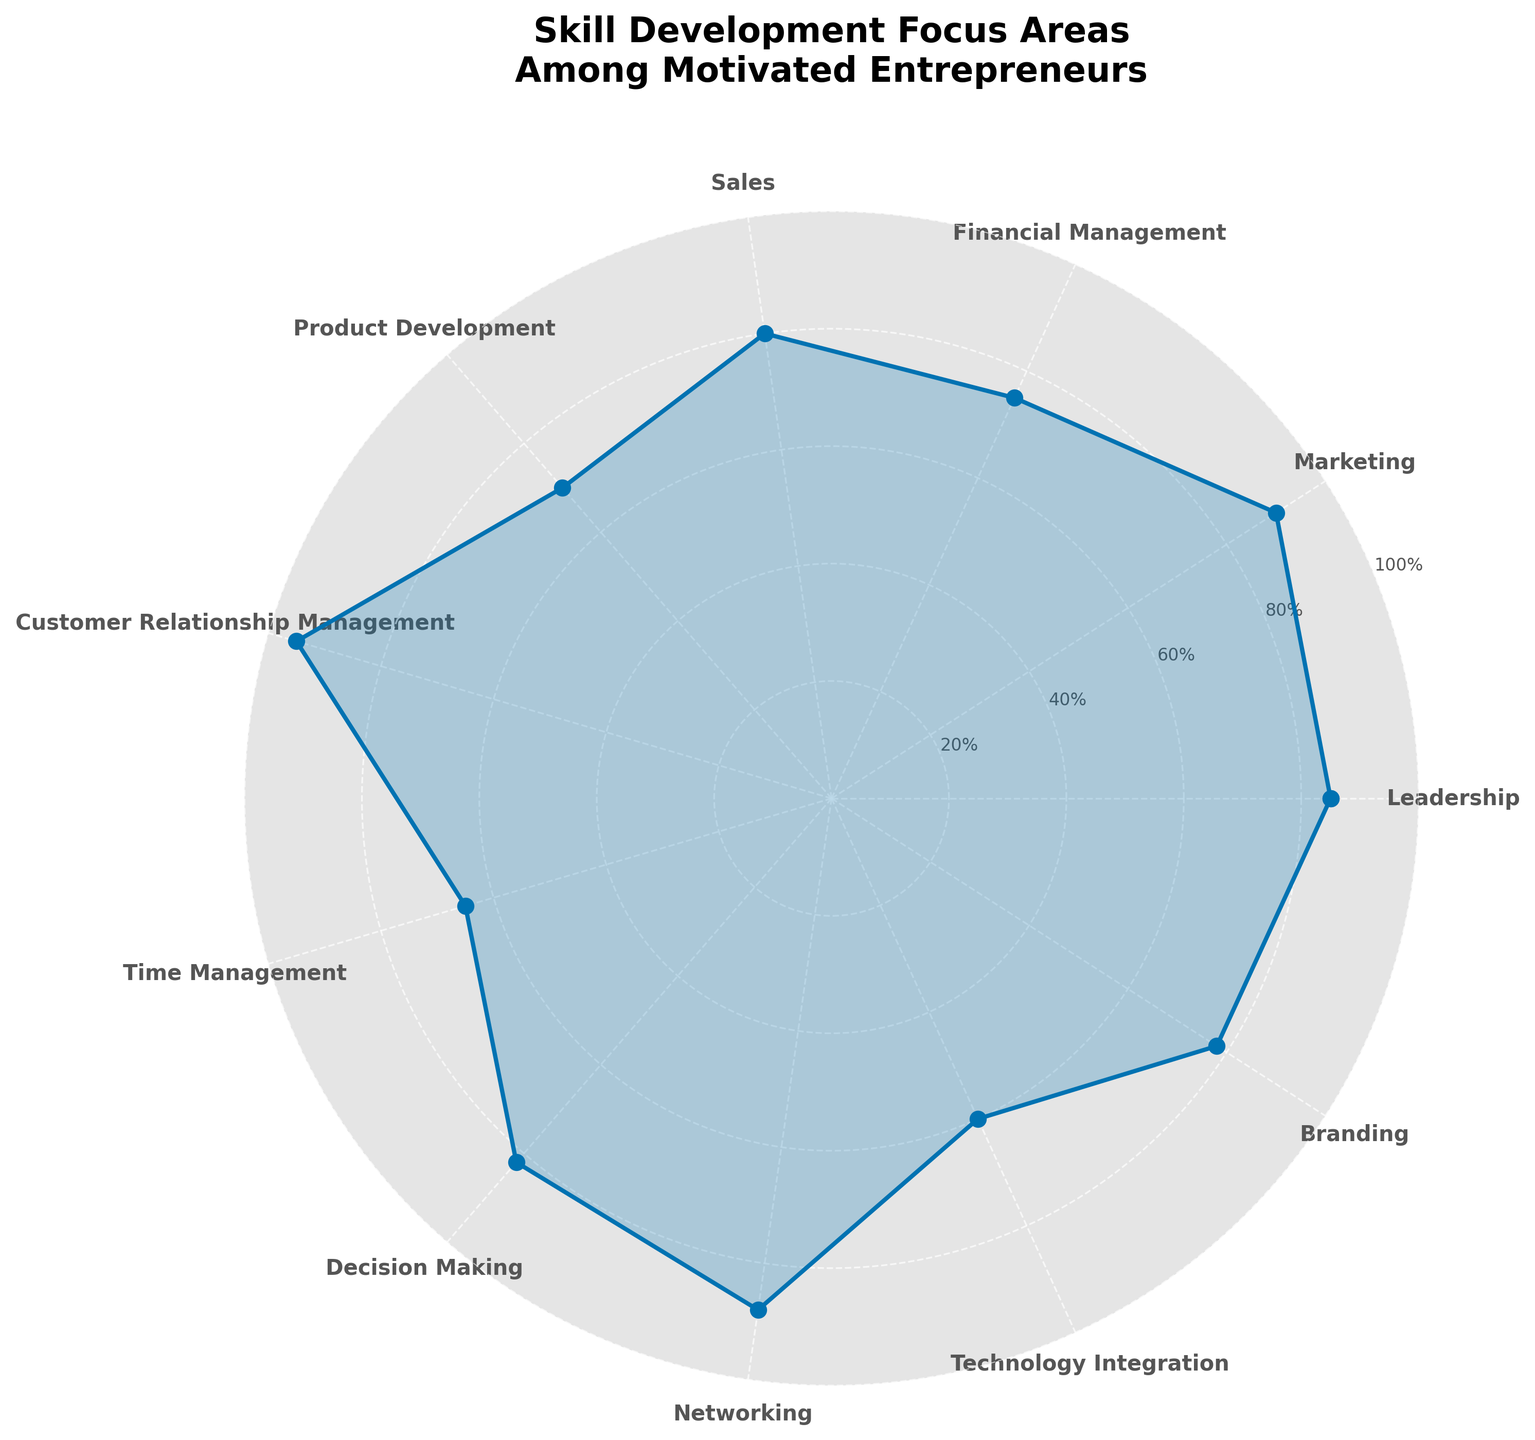What's the title of the plot? The title is displayed at the top center of the plot in bold and larger font size compared to the other text.
Answer: Skill Development Focus Areas Among Motivated Entrepreneurs How many skills are represented in the chart? Count all the distinct labels along the edges of the chart.
Answer: 11 Which skill has the highest focus level? Find the point with the highest value on the y-axis. It's marked near the edge of the chart. Corresponding label is the skill.
Answer: Customer Relationship Management What's the focus level for Technology Integration? Locate the label for Technology Integration and read off the corresponding y-value on the plot.
Answer: 60 Which two skills have focus levels closest to each other? Compare the focus levels and identify the pair with the smallest difference.
Answer: Branding and Decision Making What's the average focus level among all the skills? Add all focus levels and divide by the number of skills: (85 + 90 + 75 + 80 + 70 + 95 + 65 + 82 + 88 + 60 + 78) / 11.
Answer: 78.1 What is the difference between the highest and lowest focus levels? Subtract the smallest focus level from the largest: 95 - 60.
Answer: 35 Are there more skills with a focus level above or below 80%? Count the number of skills above and below 80% and compare.
Answer: More below What's the focus level for Sales compared to Marketing? Find the focus levels for both Sales and Marketing and compare them.
Answer: Marketing has a higher focus level than Sales What shape does the plot make when connecting all the focus levels? Observe the shape formed by connecting all the data points on the polar plot.
Answer: Polygon (11-sided) 